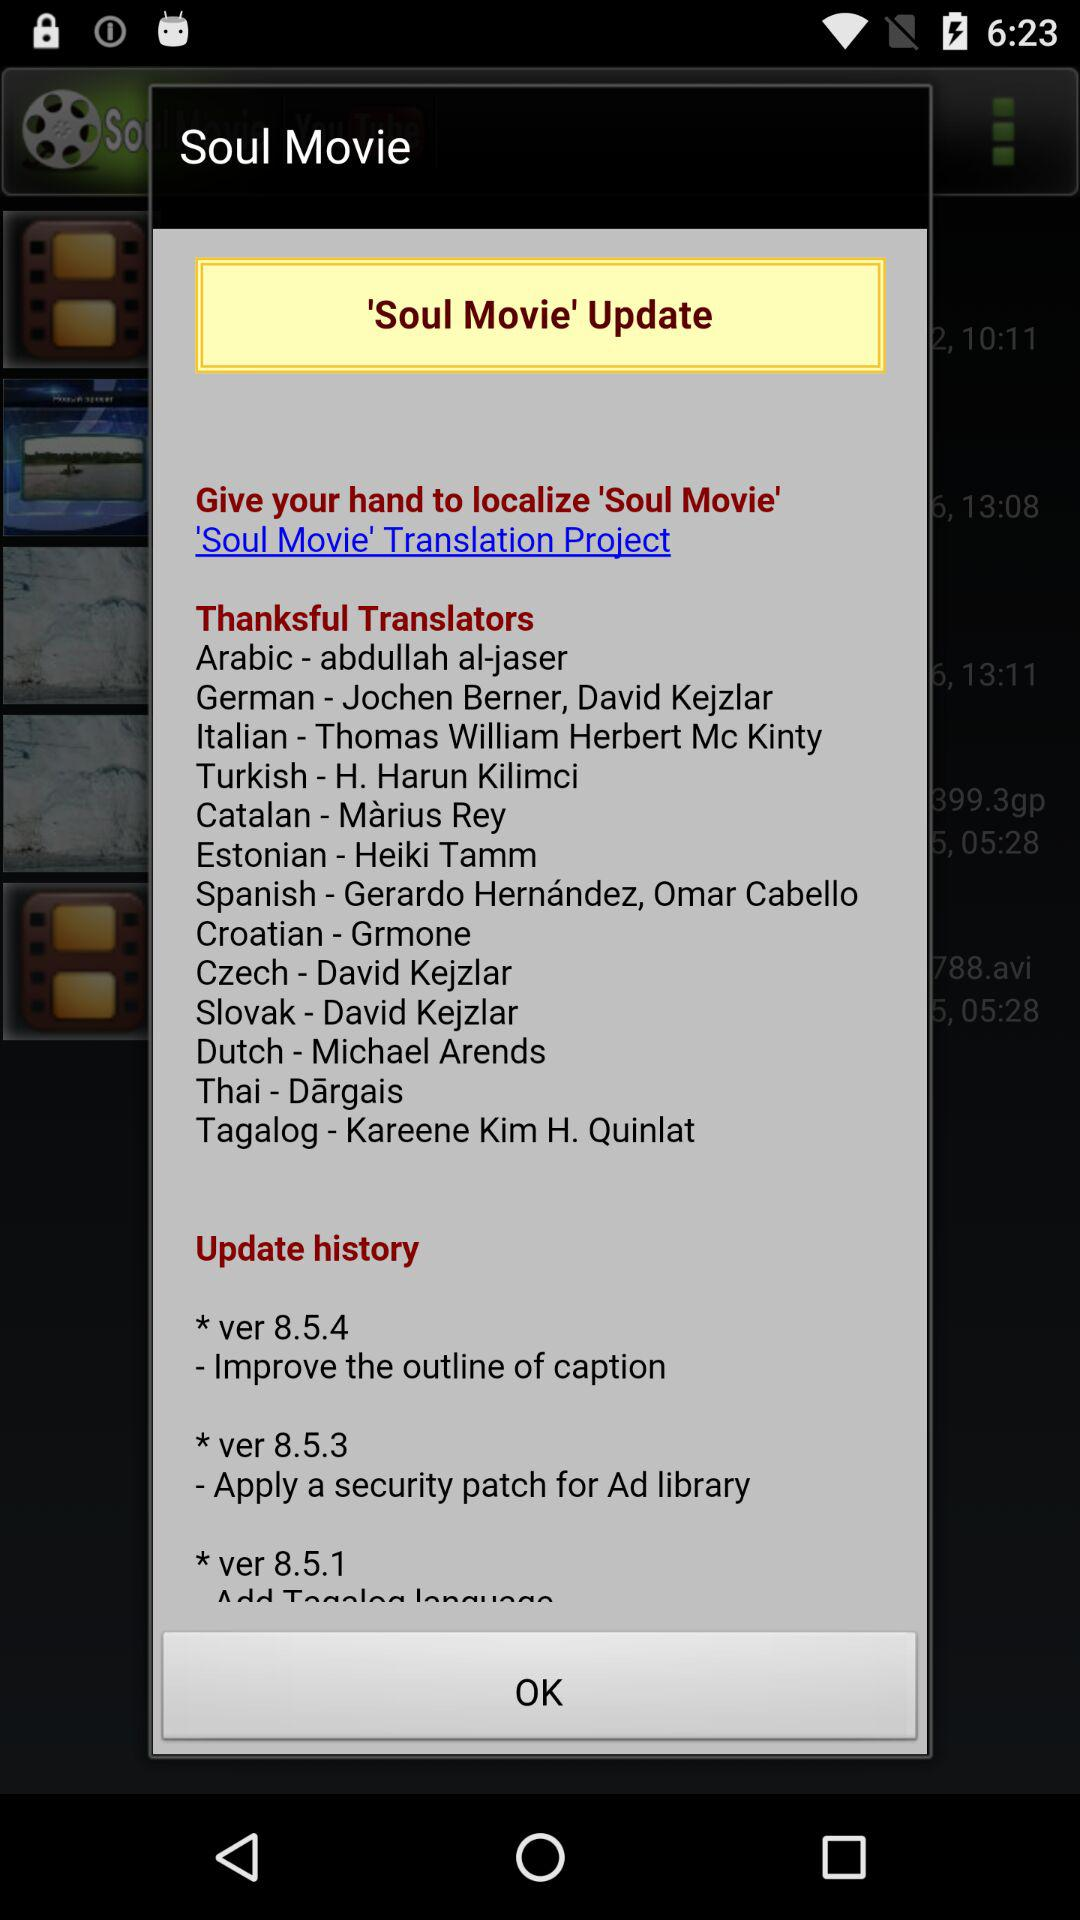What are the improvements in version 8.5.4? There is an improvement in the "outline of caption". 